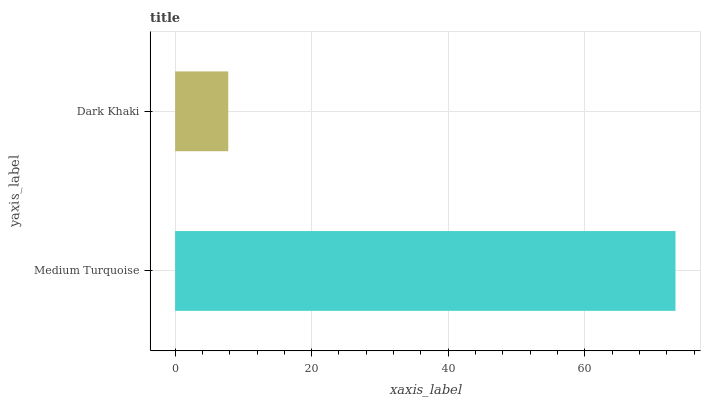Is Dark Khaki the minimum?
Answer yes or no. Yes. Is Medium Turquoise the maximum?
Answer yes or no. Yes. Is Dark Khaki the maximum?
Answer yes or no. No. Is Medium Turquoise greater than Dark Khaki?
Answer yes or no. Yes. Is Dark Khaki less than Medium Turquoise?
Answer yes or no. Yes. Is Dark Khaki greater than Medium Turquoise?
Answer yes or no. No. Is Medium Turquoise less than Dark Khaki?
Answer yes or no. No. Is Medium Turquoise the high median?
Answer yes or no. Yes. Is Dark Khaki the low median?
Answer yes or no. Yes. Is Dark Khaki the high median?
Answer yes or no. No. Is Medium Turquoise the low median?
Answer yes or no. No. 